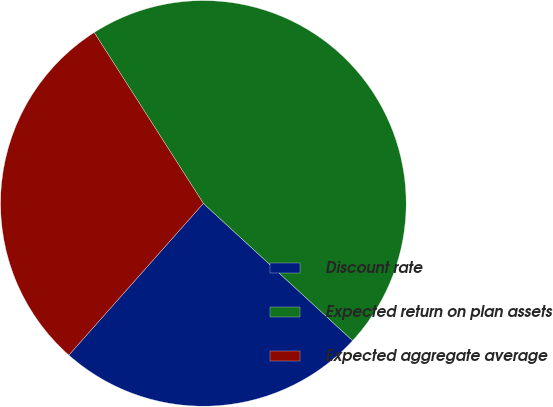Convert chart to OTSL. <chart><loc_0><loc_0><loc_500><loc_500><pie_chart><fcel>Discount rate<fcel>Expected return on plan assets<fcel>Expected aggregate average<nl><fcel>24.71%<fcel>45.88%<fcel>29.41%<nl></chart> 